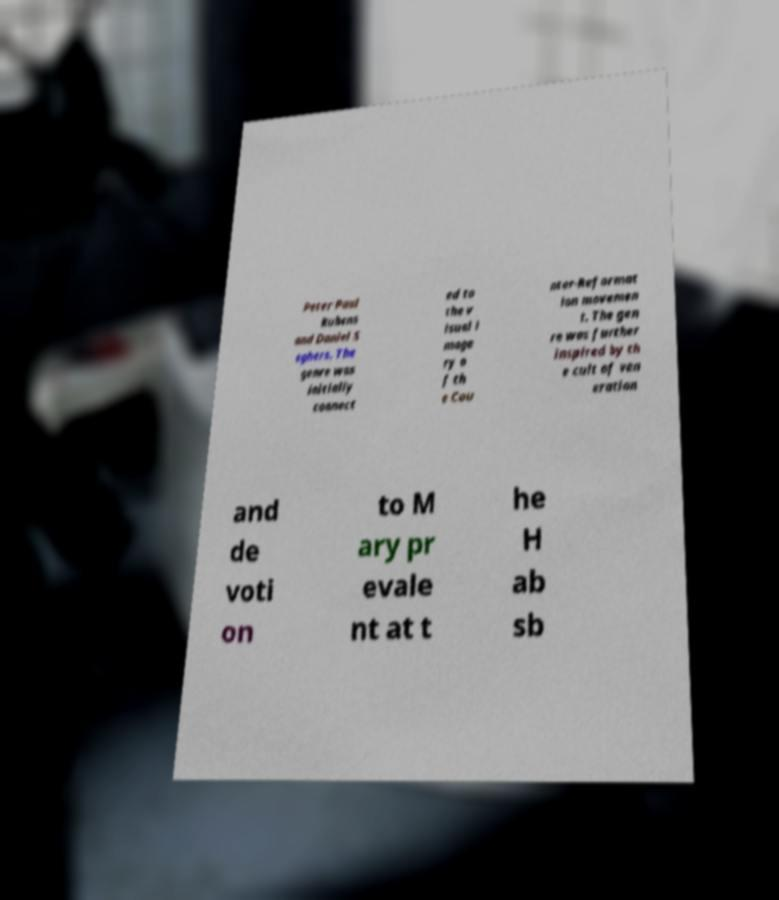Please identify and transcribe the text found in this image. Peter Paul Rubens and Daniel S eghers. The genre was initially connect ed to the v isual i mage ry o f th e Cou nter-Reformat ion movemen t. The gen re was further inspired by th e cult of ven eration and de voti on to M ary pr evale nt at t he H ab sb 